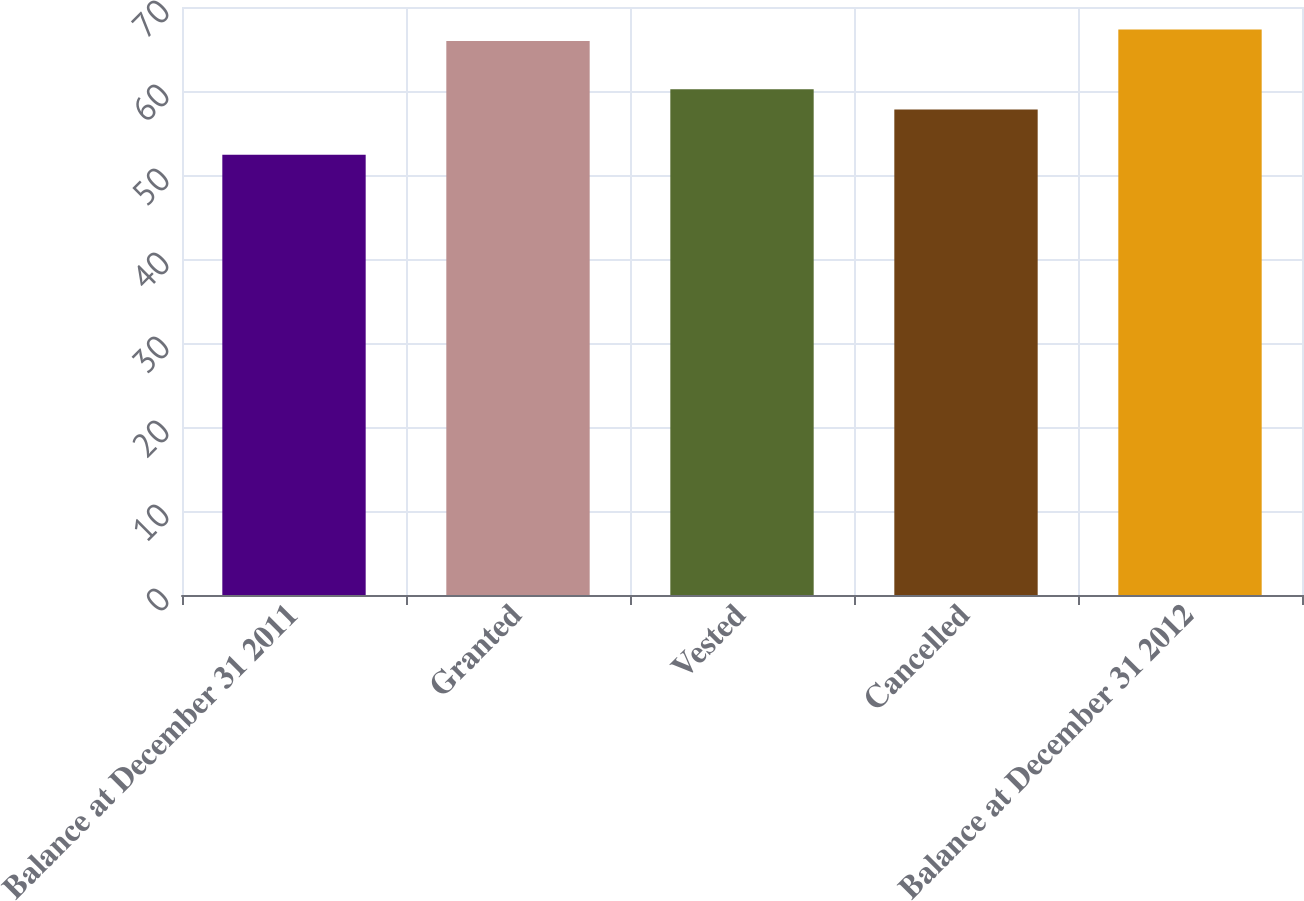Convert chart to OTSL. <chart><loc_0><loc_0><loc_500><loc_500><bar_chart><fcel>Balance at December 31 2011<fcel>Granted<fcel>Vested<fcel>Cancelled<fcel>Balance at December 31 2012<nl><fcel>52.42<fcel>65.96<fcel>60.21<fcel>57.79<fcel>67.31<nl></chart> 